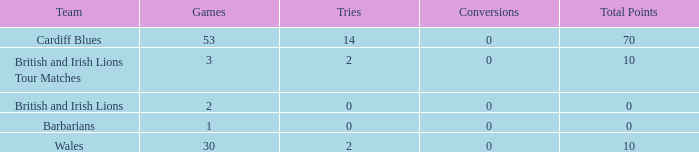What is the average number of conversions for the Cardiff Blues with less than 14 tries? None. 